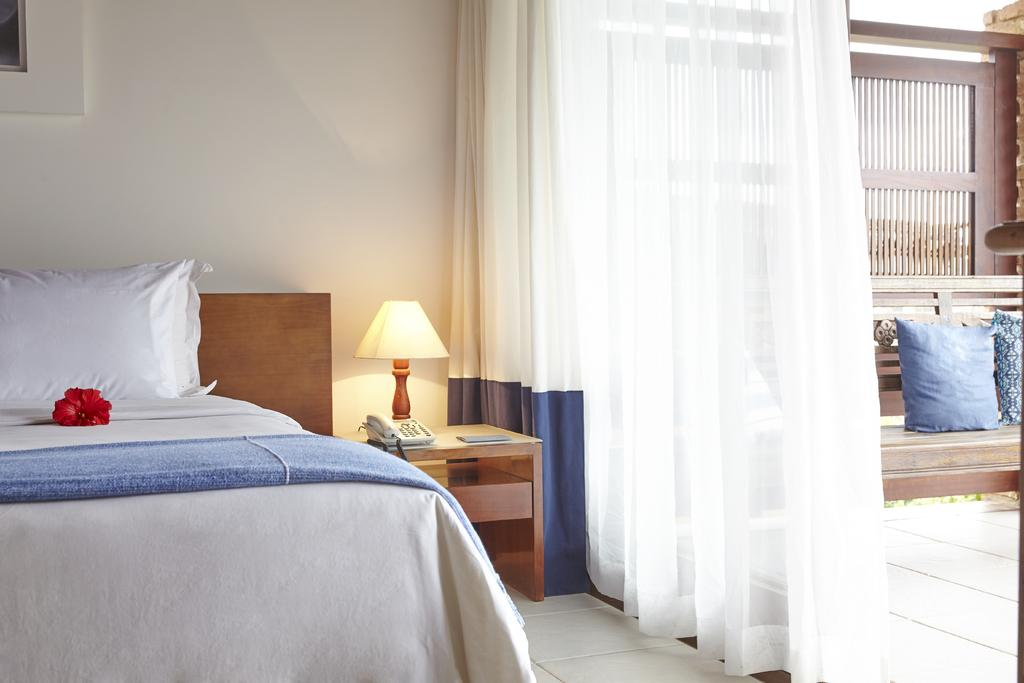What color is the bed in the image? The bed in the image is white. What decorative item can be seen on the bed? There is a red flower on the bed. What furniture is present in the image besides the bed? There is a table in the image. What items are on the table? The table has a telephone and a lamp on it. What type of window treatment is visible in the image? There is a white curtain beside the table. What type of songs can be heard coming from the rose in the image? There is no rose present in the image, and therefore no songs can be heard from it. 